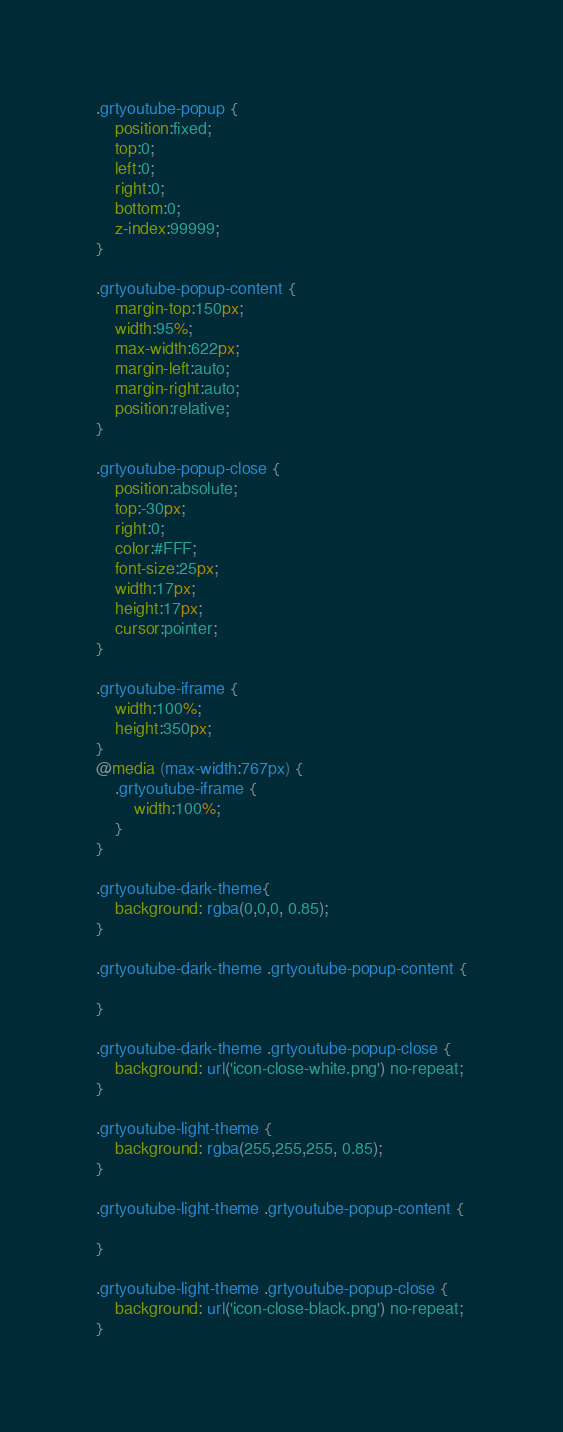Convert code to text. <code><loc_0><loc_0><loc_500><loc_500><_CSS_>.grtyoutube-popup {
	position:fixed;
	top:0;
	left:0;
	right:0;
	bottom:0;
	z-index:99999;
}

.grtyoutube-popup-content {
	margin-top:150px;
	width:95%;
	max-width:622px;
	margin-left:auto;
	margin-right:auto;
	position:relative;
}

.grtyoutube-popup-close {
	position:absolute;
	top:-30px;
	right:0;
	color:#FFF;
	font-size:25px;
	width:17px;
	height:17px;
	cursor:pointer;
}

.grtyoutube-iframe {
	width:100%;
	height:350px;
}
@media (max-width:767px) {
	.grtyoutube-iframe {
		width:100%;
	}
}

.grtyoutube-dark-theme{
	background: rgba(0,0,0, 0.85);
}

.grtyoutube-dark-theme .grtyoutube-popup-content {
	
}

.grtyoutube-dark-theme .grtyoutube-popup-close {
	background: url('icon-close-white.png') no-repeat;
}

.grtyoutube-light-theme {
	background: rgba(255,255,255, 0.85);
}

.grtyoutube-light-theme .grtyoutube-popup-content {

}

.grtyoutube-light-theme .grtyoutube-popup-close {
	background: url('icon-close-black.png') no-repeat;
}


</code> 